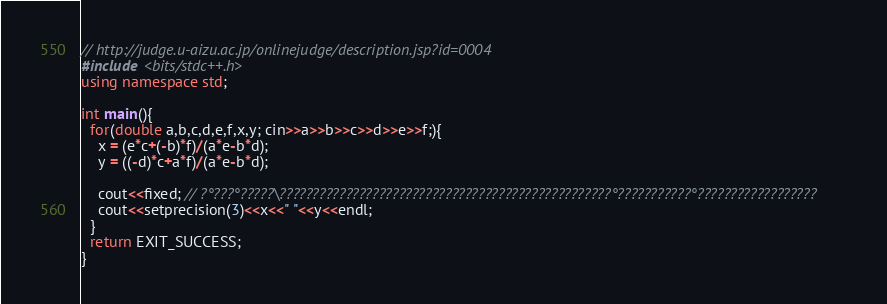<code> <loc_0><loc_0><loc_500><loc_500><_C++_>// http://judge.u-aizu.ac.jp/onlinejudge/description.jsp?id=0004
#include <bits/stdc++.h>
using namespace std;

int main(){
  for(double a,b,c,d,e,f,x,y; cin>>a>>b>>c>>d>>e>>f;){
    x = (e*c+(-b)*f)/(a*e-b*d);
    y = ((-d)*c+a*f)/(a*e-b*d);

    cout<<fixed; // ?°???°?????\??????????????????????????????????????????????????°???????????°??????????????????
    cout<<setprecision(3)<<x<<" "<<y<<endl;
  }
  return EXIT_SUCCESS;
}</code> 